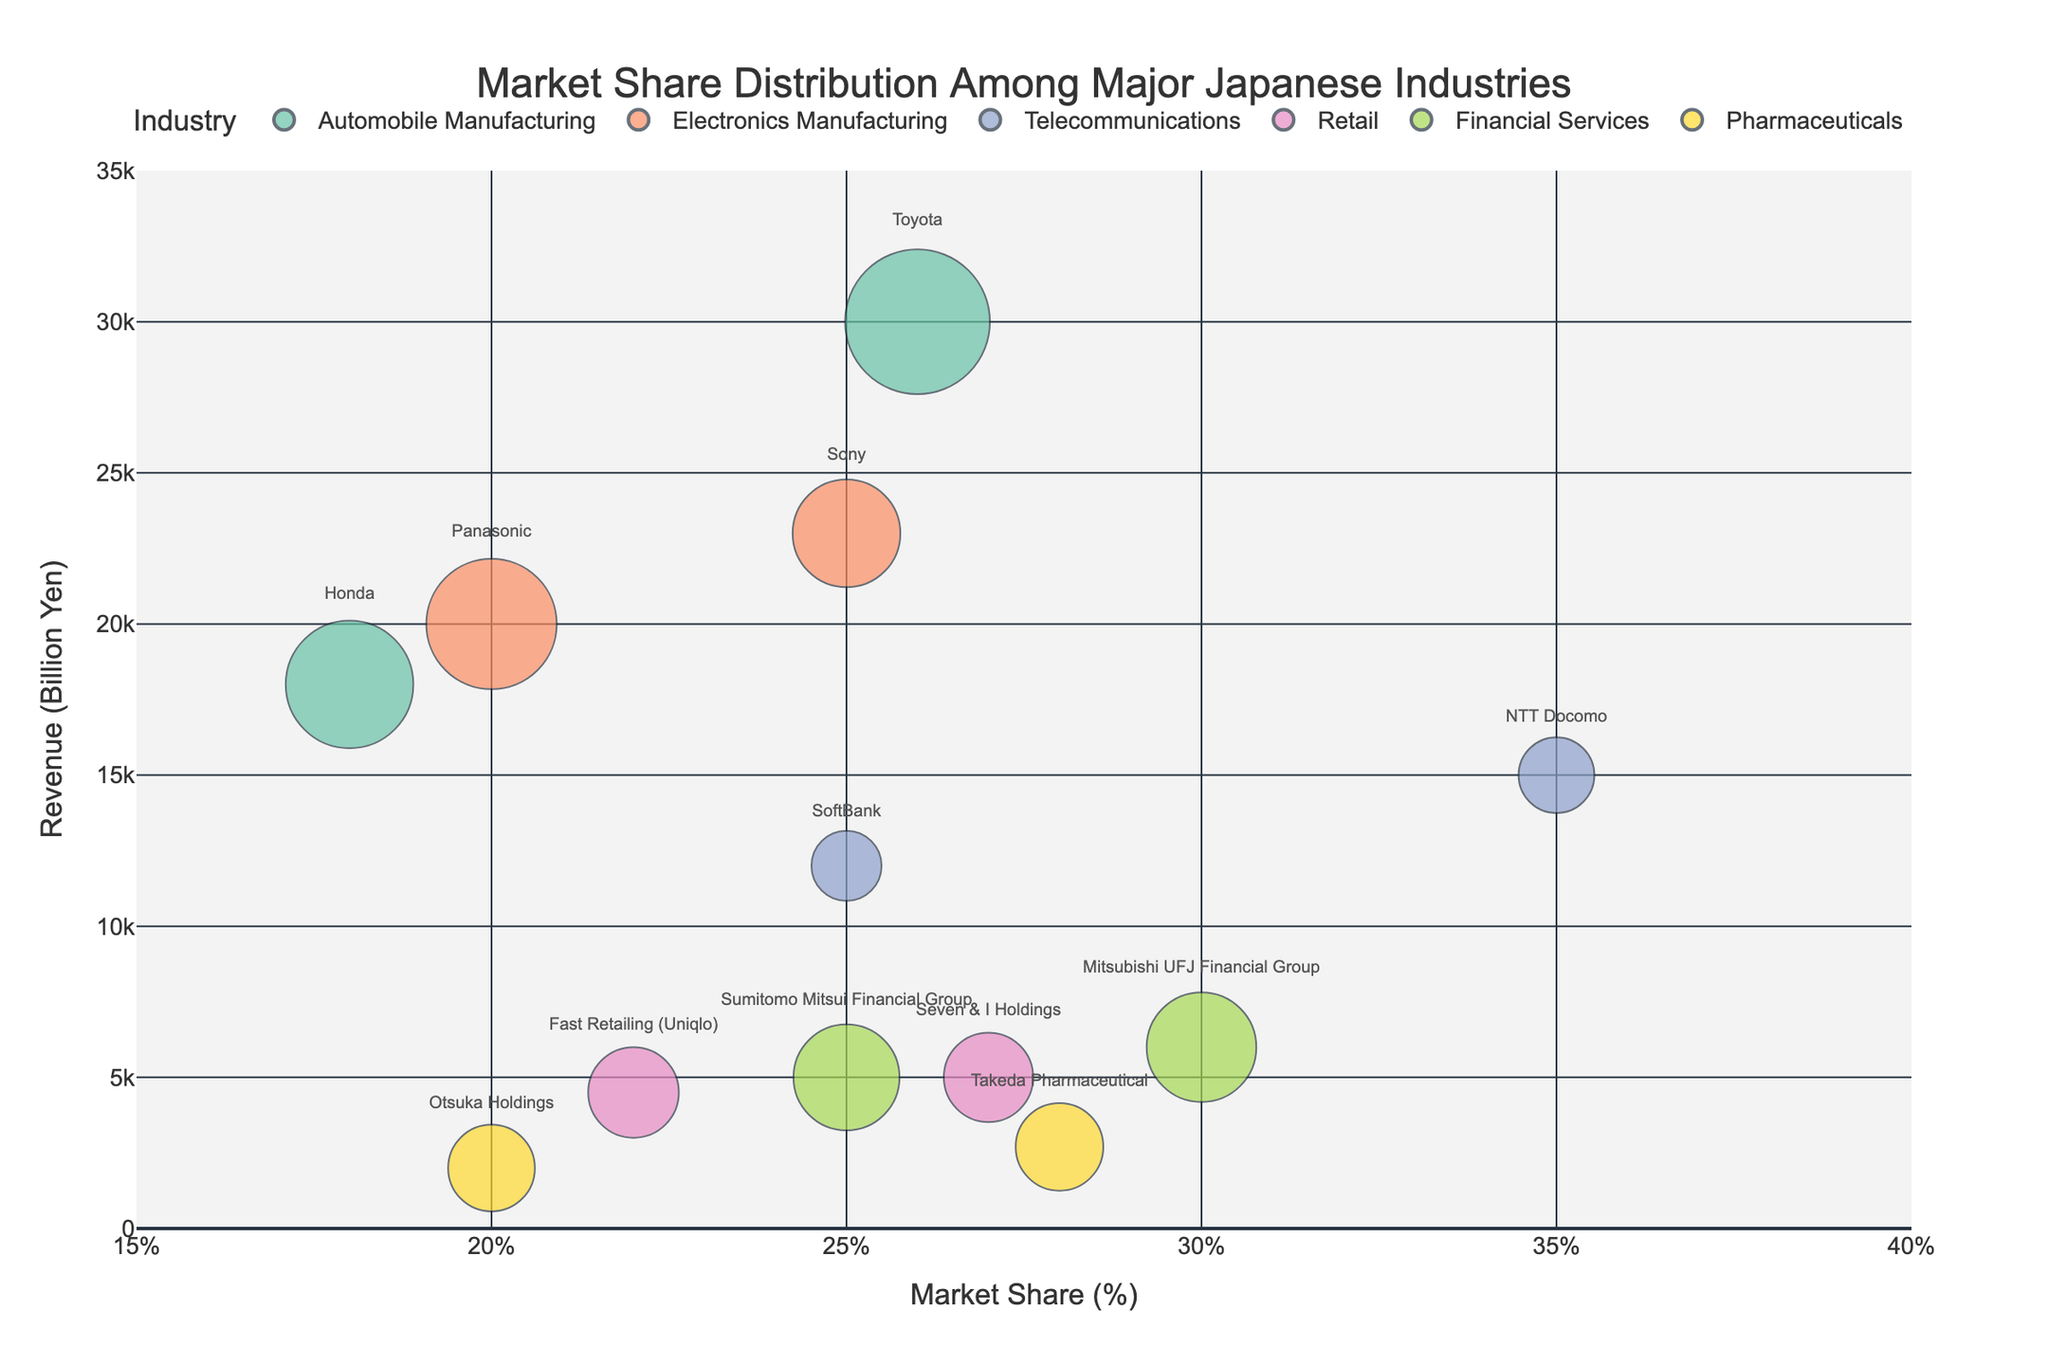How many industries are represented in the chart? Count the number of unique industries displayed in the legend on the right side of the chart. There are six colors, each representing a different industry.
Answer: 6 Which company has the highest market share? Look at the x-axis (Market Share) and identify the bubble farthest to the right. NTT Docomo has the highest market share at 35%.
Answer: NTT Docomo What is the revenue of the company with the largest bubble size in the Retail industry? Locate the bubble for the Retail industry and identify the one with the largest size. Seven & I Holdings is the largest bubble, with a revenue of 5000 Billion Yen.
Answer: 5000 Billion Yen Compare the market shares of Toyota and Honda. What is the difference? Identify the bubbles for Toyota and Honda in the Automobile Manufacturing industry on the x-axis (Market Share). Toyota has a market share of 26%, and Honda has 18%. Calculate the difference: 26% - 18% = 8%.
Answer: 8% Which company in the Electronics Manufacturing industry has a higher revenue, Sony or Panasonic? Look at the bubbles in the Electronics Manufacturing industry. Sony's bubble is at 23000 Billion Yen on the y-axis, while Panasonic's is at 20000 Billion Yen. Sony has a higher revenue.
Answer: Sony What is the combined revenue of the Telecommunications industry? Add the revenue values of NTT Docomo (15000 Billion Yen) and SoftBank (12000 Billion Yen): 15000 + 12000 = 27000 Billion Yen.
Answer: 27000 Billion Yen Which industry has the smallest range of revenues among its companies? Compare the decrease in revenue values among companies within each industry. The Financial Services industry has the smallest range: Mitsubishi UFJ Financial Group (6000 Billion Yen) and Sumitomo Mitsui Financial Group (5000 Billion Yen), giving a difference of 6000 - 5000 = 1000 Billion Yen.
Answer: Financial Services What is the average market share of companies in the Pharmaceutical industry? Identify the market shares for Takeda Pharmaceutical (28%) and Otsuka Holdings (20%). Calculate the average: (28 + 20) / 2 = 24%.
Answer: 24% How many companies have a market share above 25%? Count the number of bubbles positioned to the right of the 25% mark on the x-axis. There are four companies: Toyota, Sony, NTT Docomo, Seven & I Holdings.
Answer: 4 Which industry has the highest revenue for its leading company? Look at the highest bubbles in each industry. The highest bubble overall belongs to Toyota in the Automobile Manufacturing industry with 30000 Billion Yen.
Answer: Automobile Manufacturing 